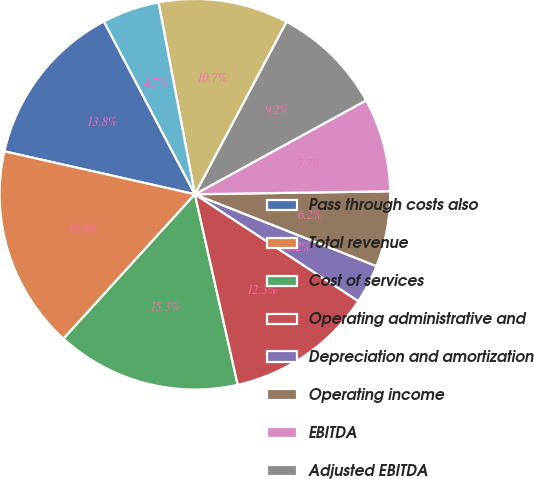Convert chart to OTSL. <chart><loc_0><loc_0><loc_500><loc_500><pie_chart><fcel>Pass through costs also<fcel>Total revenue<fcel>Cost of services<fcel>Operating administrative and<fcel>Depreciation and amortization<fcel>Operating income<fcel>EBITDA<fcel>Adjusted EBITDA<fcel>Fee revenue<fcel>Revenue<nl><fcel>13.76%<fcel>16.78%<fcel>15.27%<fcel>12.26%<fcel>3.22%<fcel>6.24%<fcel>7.74%<fcel>9.25%<fcel>10.75%<fcel>4.73%<nl></chart> 